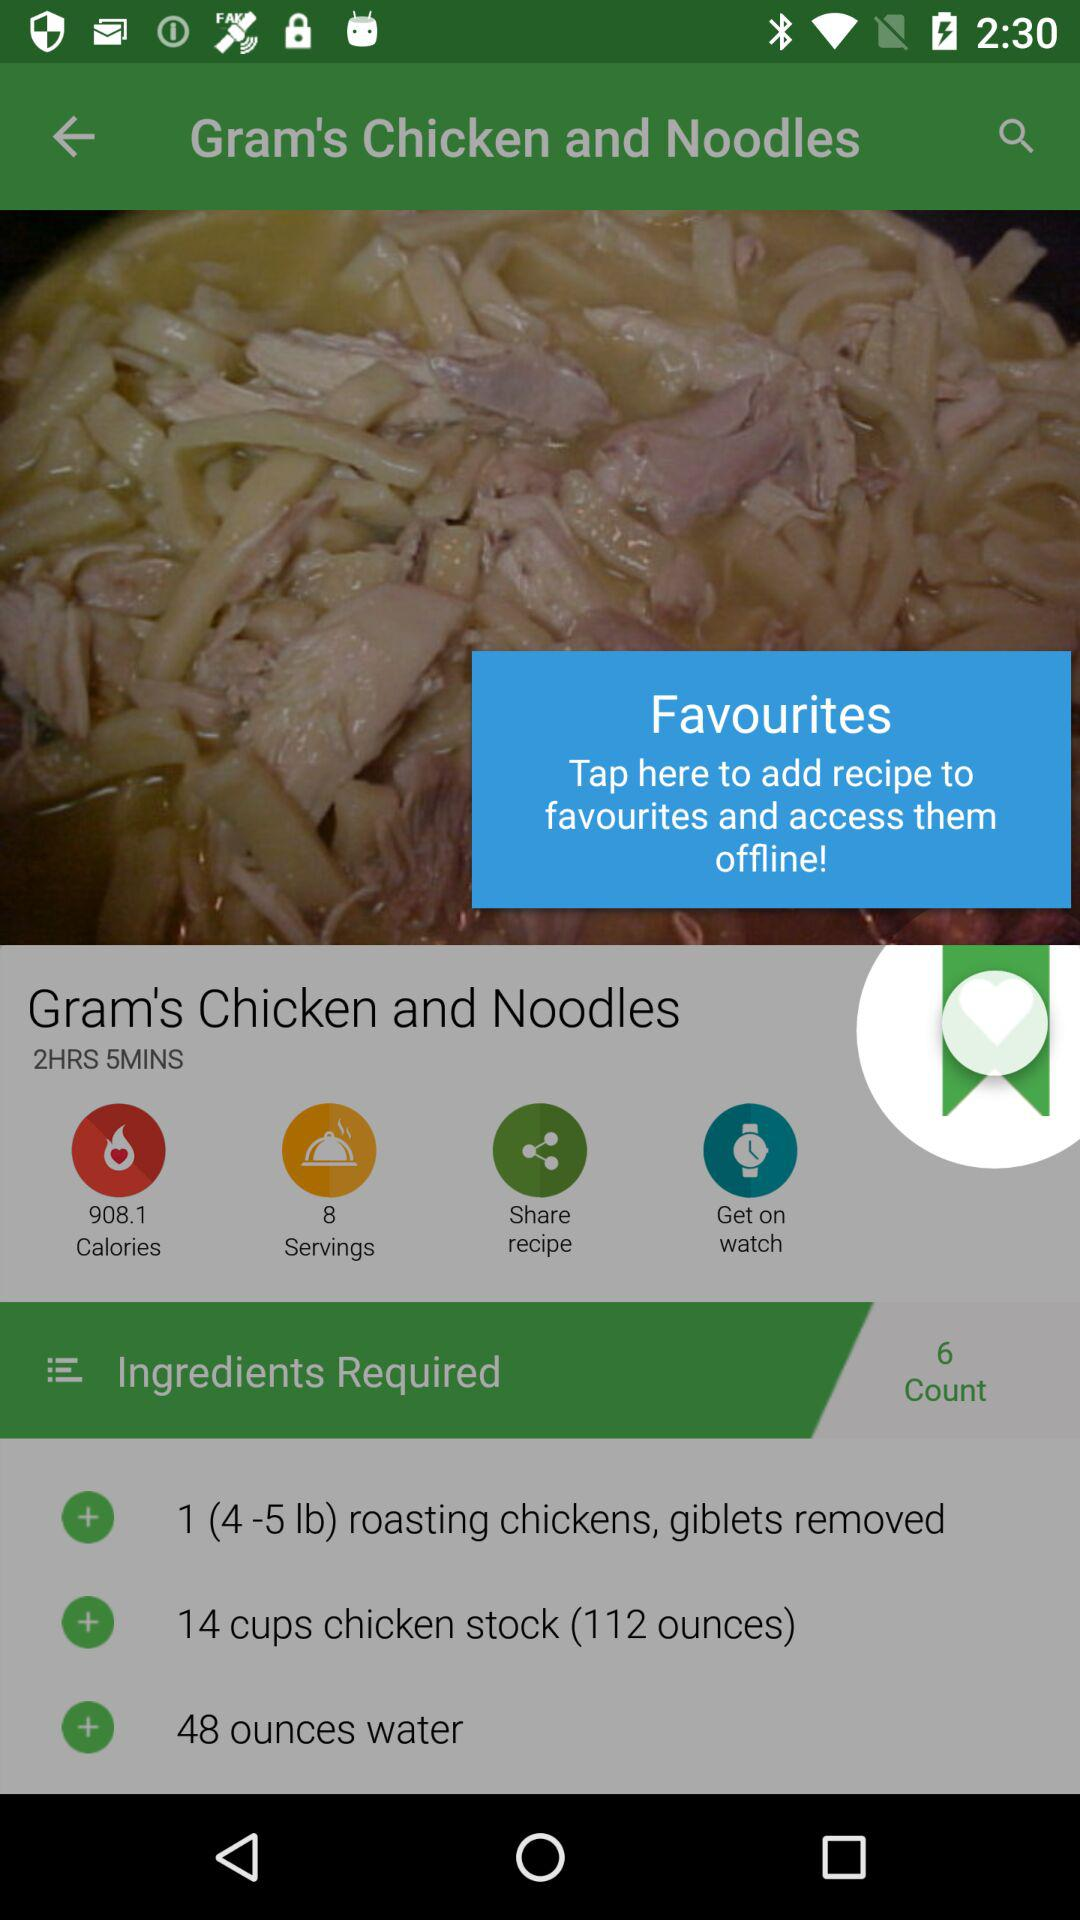What is the number of calories? The number of calories is 908.1. 